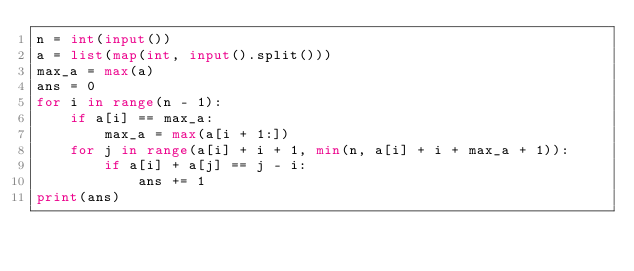Convert code to text. <code><loc_0><loc_0><loc_500><loc_500><_Python_>n = int(input())
a = list(map(int, input().split()))
max_a = max(a)
ans = 0
for i in range(n - 1):
    if a[i] == max_a:
        max_a = max(a[i + 1:])
    for j in range(a[i] + i + 1, min(n, a[i] + i + max_a + 1)):
        if a[i] + a[j] == j - i:
            ans += 1
print(ans)</code> 